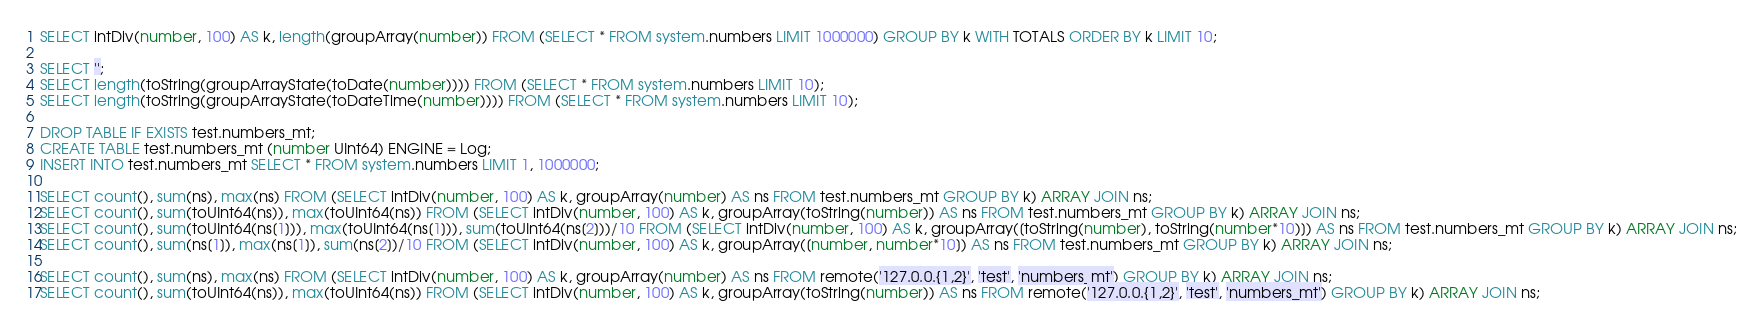Convert code to text. <code><loc_0><loc_0><loc_500><loc_500><_SQL_>SELECT intDiv(number, 100) AS k, length(groupArray(number)) FROM (SELECT * FROM system.numbers LIMIT 1000000) GROUP BY k WITH TOTALS ORDER BY k LIMIT 10;

SELECT '';
SELECT length(toString(groupArrayState(toDate(number)))) FROM (SELECT * FROM system.numbers LIMIT 10);
SELECT length(toString(groupArrayState(toDateTime(number)))) FROM (SELECT * FROM system.numbers LIMIT 10);

DROP TABLE IF EXISTS test.numbers_mt;
CREATE TABLE test.numbers_mt (number UInt64) ENGINE = Log;
INSERT INTO test.numbers_mt SELECT * FROM system.numbers LIMIT 1, 1000000;

SELECT count(), sum(ns), max(ns) FROM (SELECT intDiv(number, 100) AS k, groupArray(number) AS ns FROM test.numbers_mt GROUP BY k) ARRAY JOIN ns;
SELECT count(), sum(toUInt64(ns)), max(toUInt64(ns)) FROM (SELECT intDiv(number, 100) AS k, groupArray(toString(number)) AS ns FROM test.numbers_mt GROUP BY k) ARRAY JOIN ns;
SELECT count(), sum(toUInt64(ns[1])), max(toUInt64(ns[1])), sum(toUInt64(ns[2]))/10 FROM (SELECT intDiv(number, 100) AS k, groupArray([toString(number), toString(number*10)]) AS ns FROM test.numbers_mt GROUP BY k) ARRAY JOIN ns;
SELECT count(), sum(ns[1]), max(ns[1]), sum(ns[2])/10 FROM (SELECT intDiv(number, 100) AS k, groupArray([number, number*10]) AS ns FROM test.numbers_mt GROUP BY k) ARRAY JOIN ns;

SELECT count(), sum(ns), max(ns) FROM (SELECT intDiv(number, 100) AS k, groupArray(number) AS ns FROM remote('127.0.0.{1,2}', 'test', 'numbers_mt') GROUP BY k) ARRAY JOIN ns;
SELECT count(), sum(toUInt64(ns)), max(toUInt64(ns)) FROM (SELECT intDiv(number, 100) AS k, groupArray(toString(number)) AS ns FROM remote('127.0.0.{1,2}', 'test', 'numbers_mt') GROUP BY k) ARRAY JOIN ns;</code> 